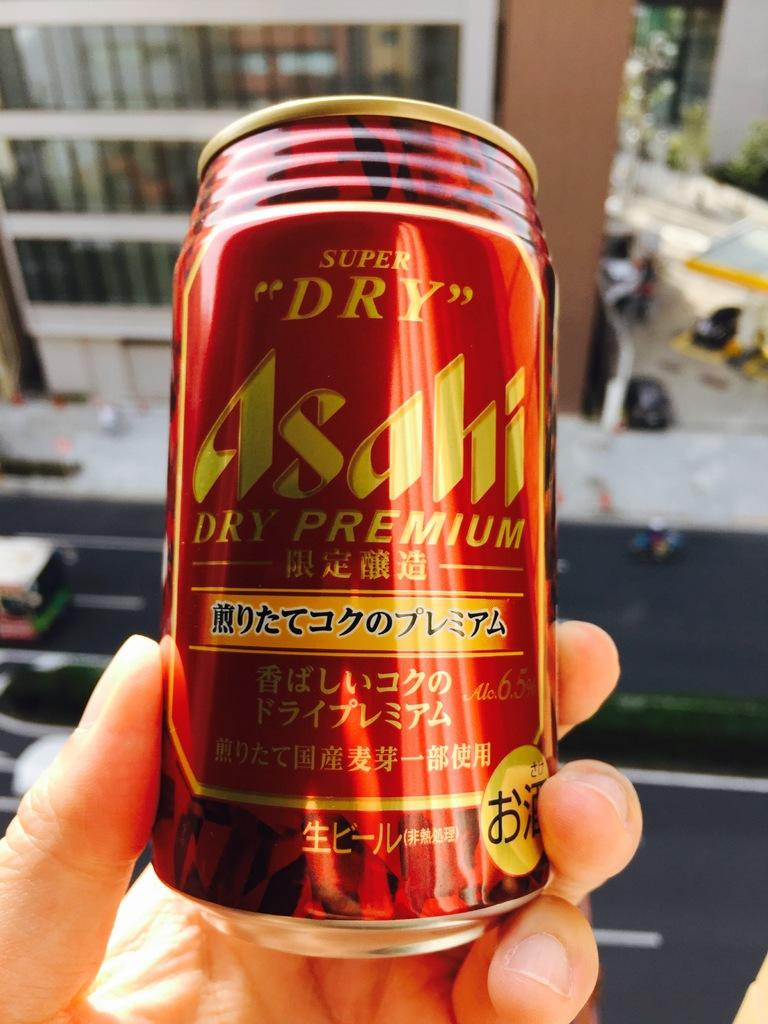Provide a one-sentence caption for the provided image. Asahi premium beer is very popular in Asian countries. 